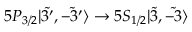<formula> <loc_0><loc_0><loc_500><loc_500>5 P _ { 3 / 2 } | \tilde { 3 ^ { \prime } } , \tilde { - 3 ^ { \prime } } \rangle \rightarrow 5 S _ { 1 / 2 } | \tilde { 3 } , \tilde { - 3 } \rangle</formula> 